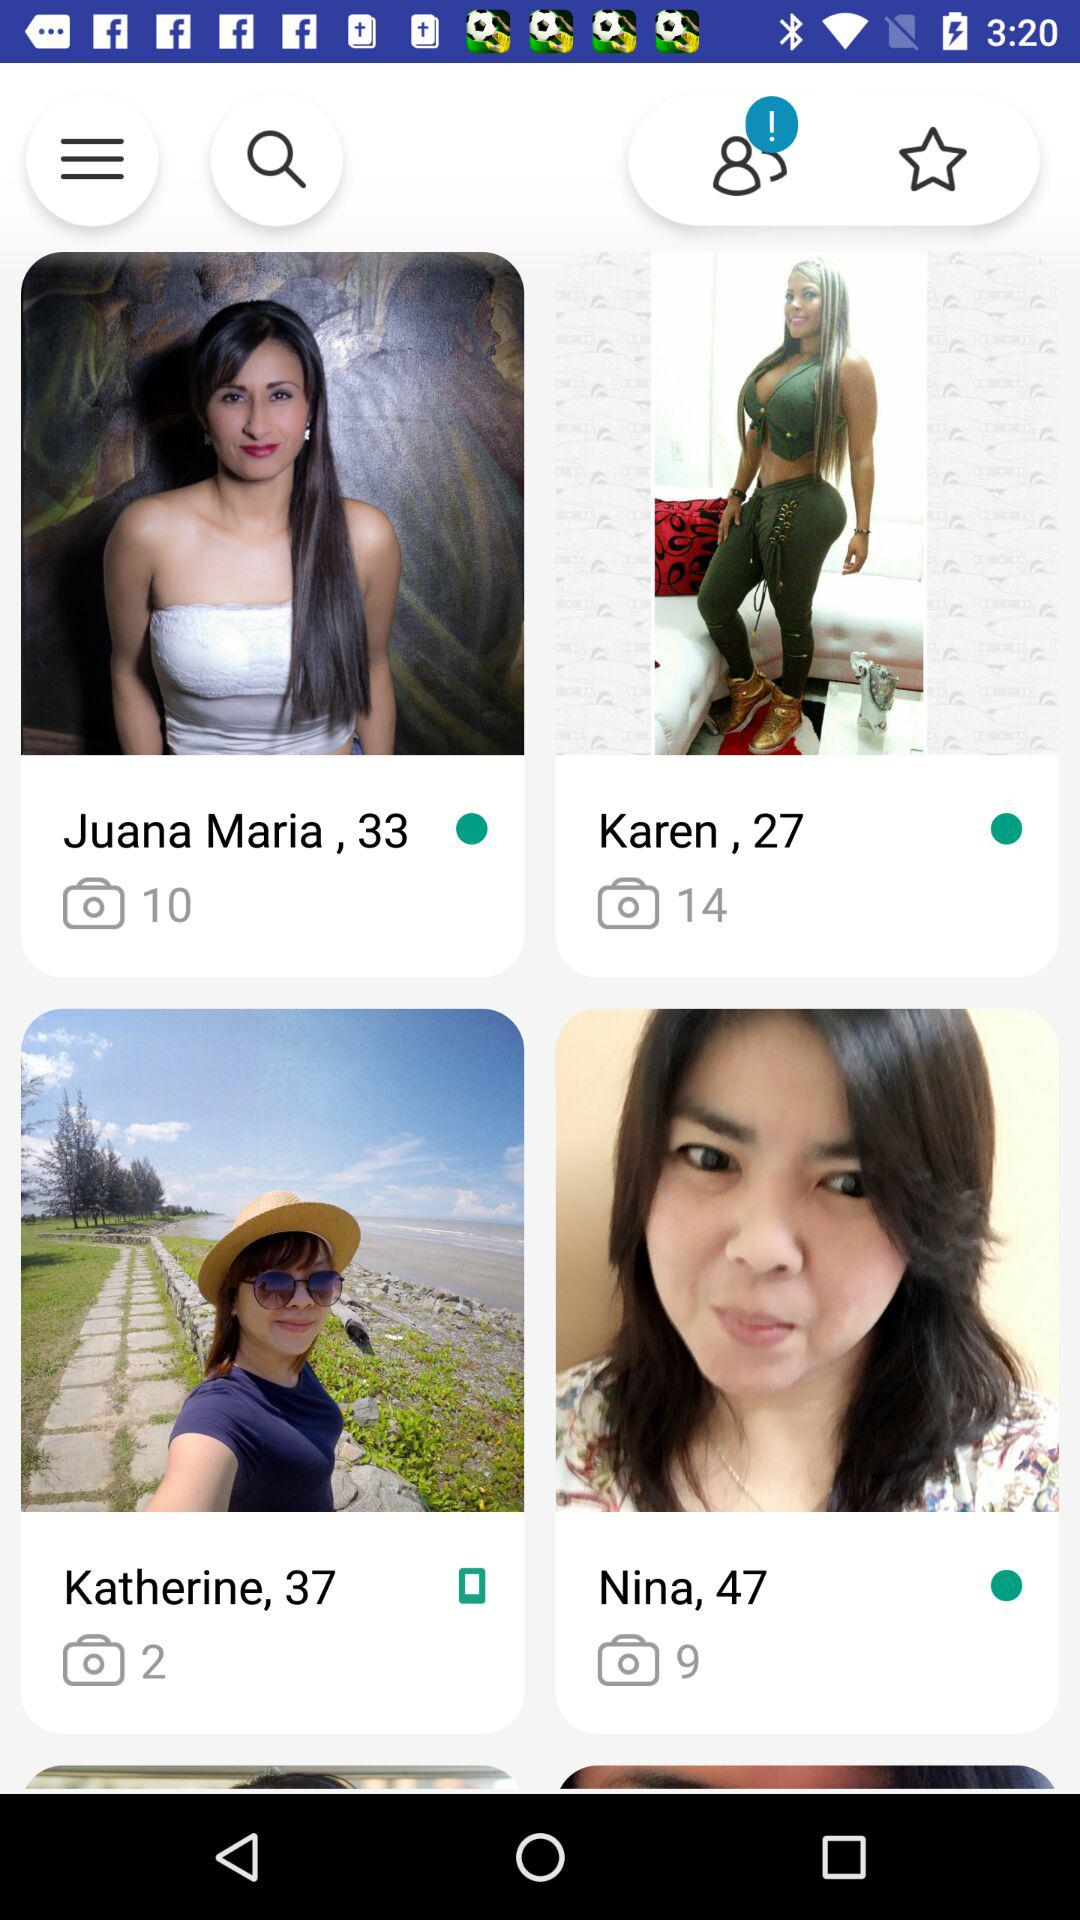How many stars is the rating?
When the provided information is insufficient, respond with <no answer>. <no answer> 